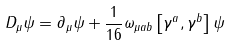Convert formula to latex. <formula><loc_0><loc_0><loc_500><loc_500>D _ { \mu } \psi = \partial _ { \mu } \psi + \frac { 1 } { 1 6 } \omega _ { \mu a b } \left [ \gamma ^ { a } , \gamma ^ { b } \right ] \psi</formula> 